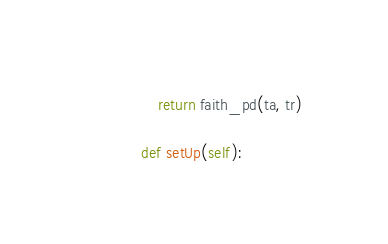Convert code to text. <code><loc_0><loc_0><loc_500><loc_500><_Python_>
        return faith_pd(ta, tr)

    def setUp(self):</code> 